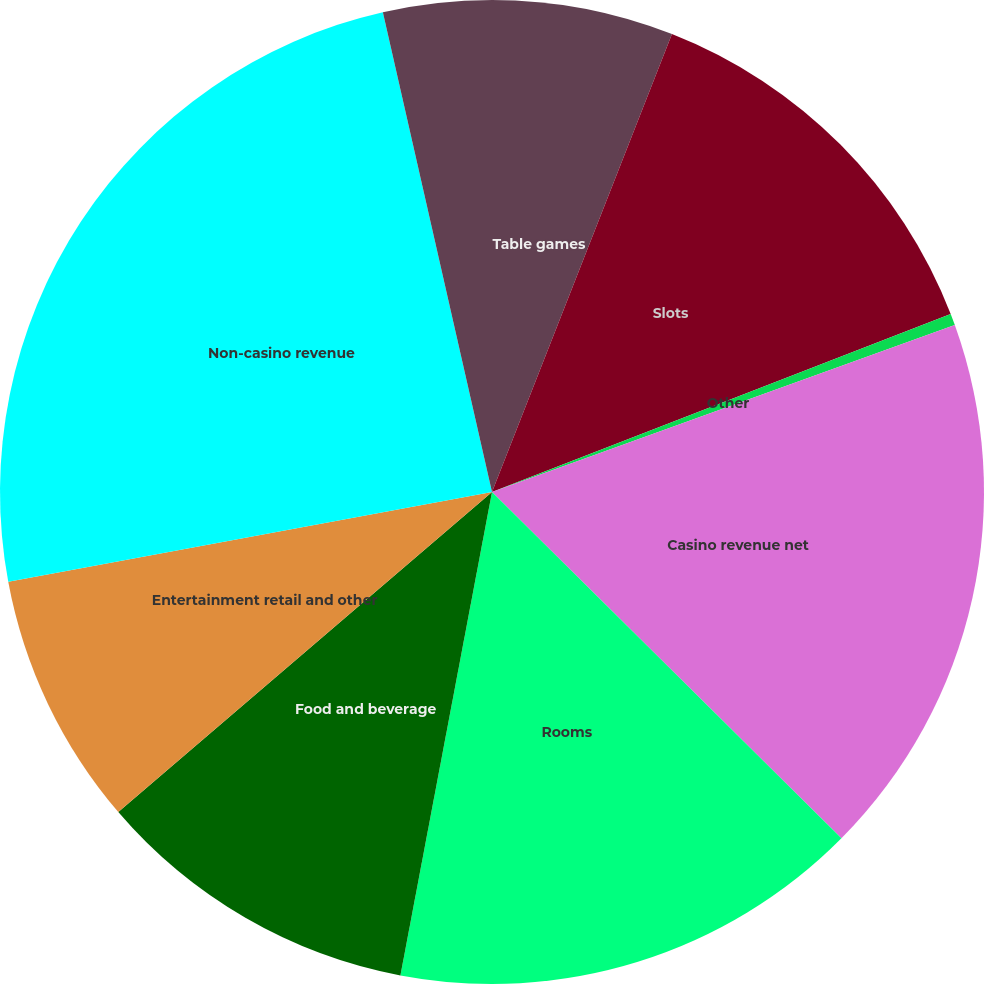Convert chart to OTSL. <chart><loc_0><loc_0><loc_500><loc_500><pie_chart><fcel>Table games<fcel>Slots<fcel>Other<fcel>Casino revenue net<fcel>Rooms<fcel>Food and beverage<fcel>Entertainment retail and other<fcel>Non-casino revenue<fcel>Less Promotional allowances<nl><fcel>5.96%<fcel>13.15%<fcel>0.38%<fcel>17.94%<fcel>15.55%<fcel>10.75%<fcel>8.35%<fcel>24.36%<fcel>3.56%<nl></chart> 